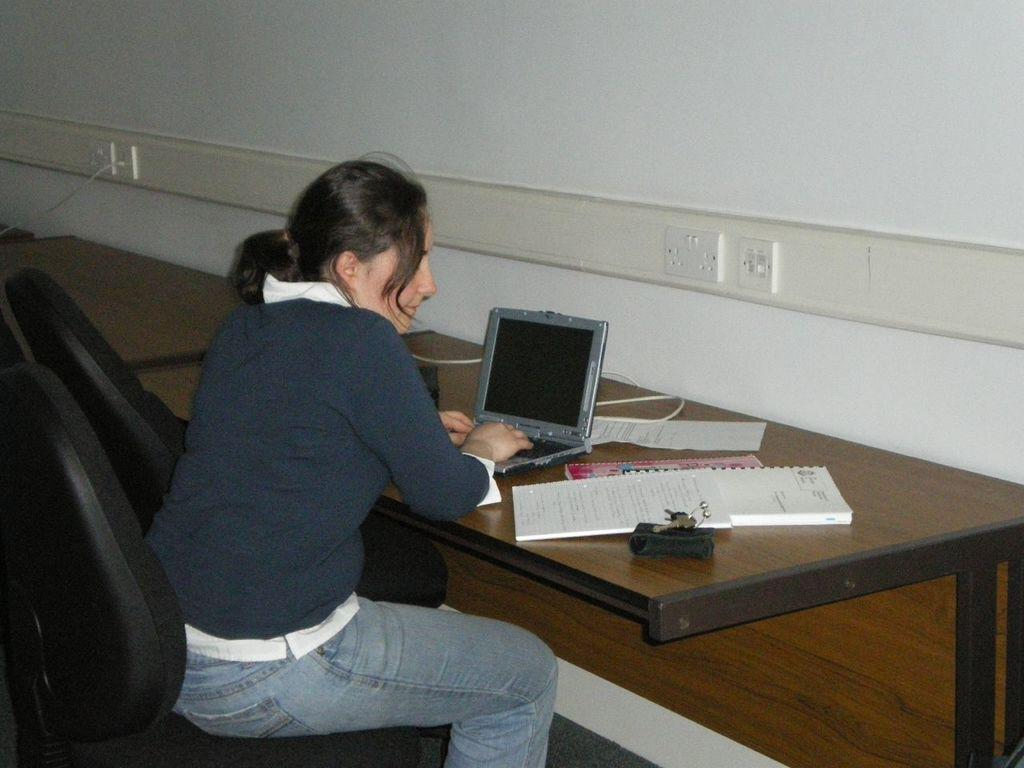Who is the main subject in the image? There is a lady in the image. What is the lady doing in the image? The lady is sitting in front of a table and operating a laptop. What else can be seen on the table besides the laptop? There are books beside the laptop. What type of clouds can be seen in the image? There are no clouds visible in the image, as it is focused on the lady and her activities at the table. 